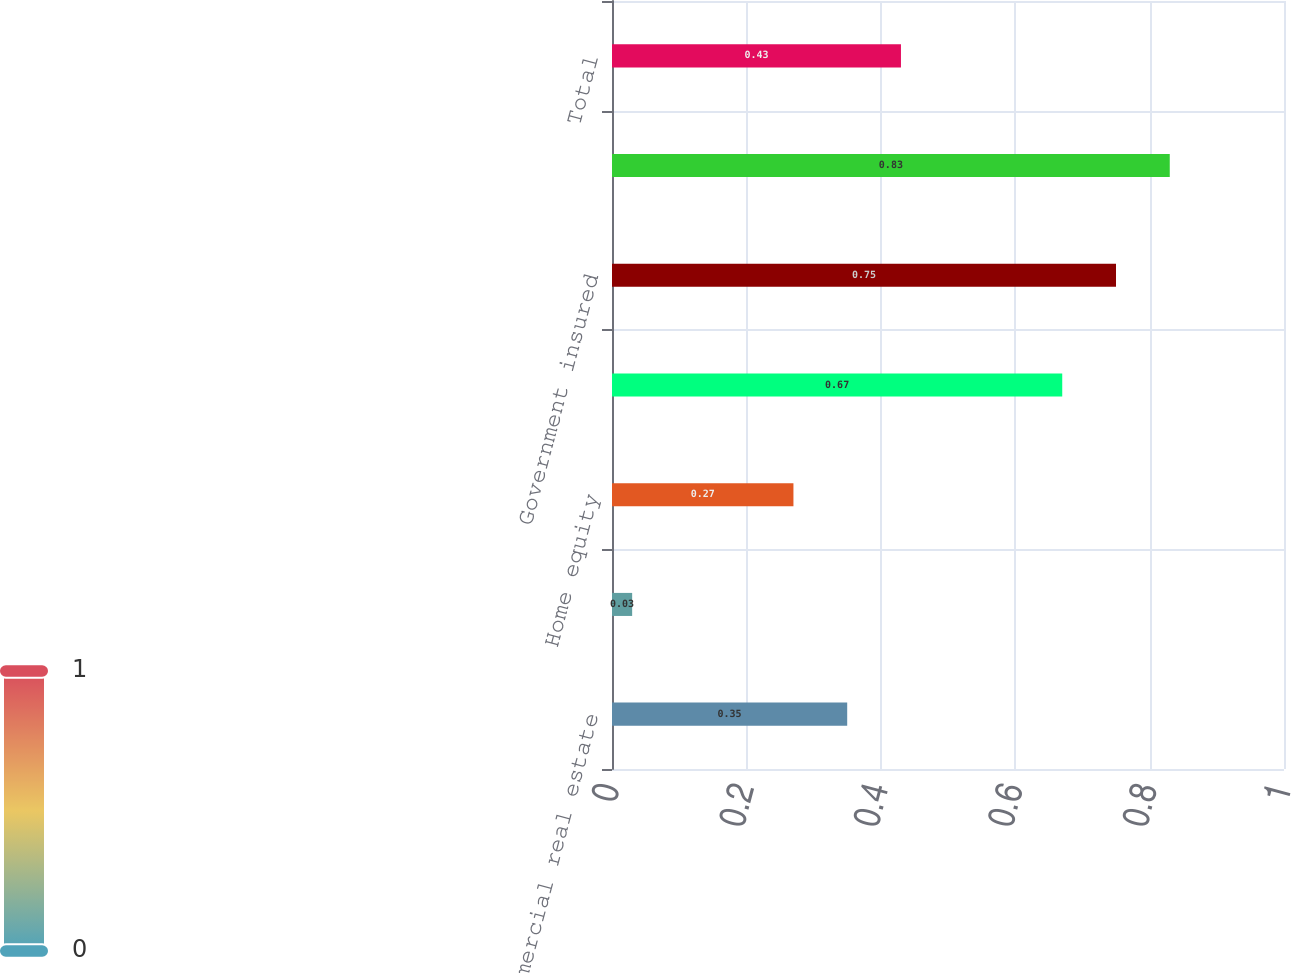Convert chart to OTSL. <chart><loc_0><loc_0><loc_500><loc_500><bar_chart><fcel>Commercial real estate<fcel>Equipment lease financing<fcel>Home equity<fcel>Non government insured<fcel>Government insured<fcel>Credit card<fcel>Total<nl><fcel>0.35<fcel>0.03<fcel>0.27<fcel>0.67<fcel>0.75<fcel>0.83<fcel>0.43<nl></chart> 